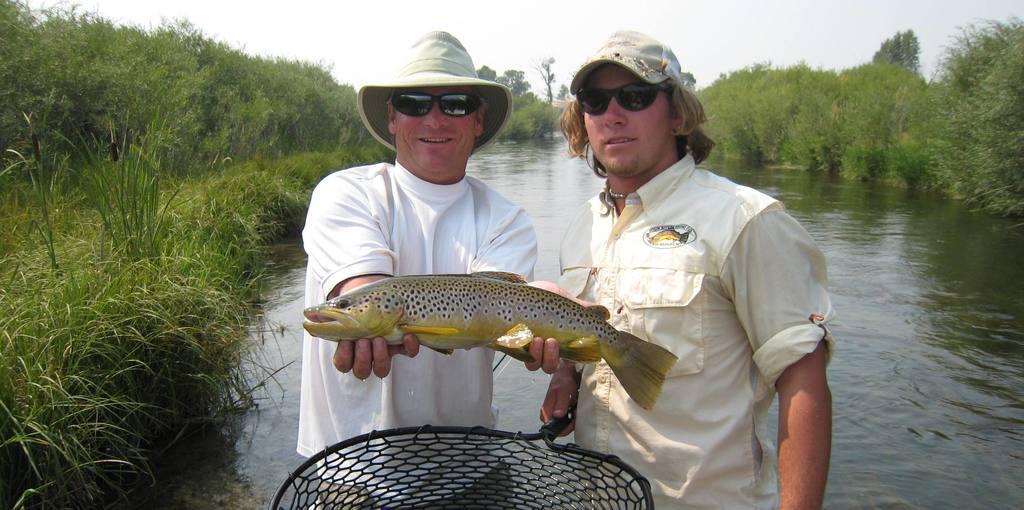Describe this image in one or two sentences. In this picture I can see two persons standing. I can see a person holding a fish and another person holding a fish net. I can see water, trees, and in the background there is the sky. 